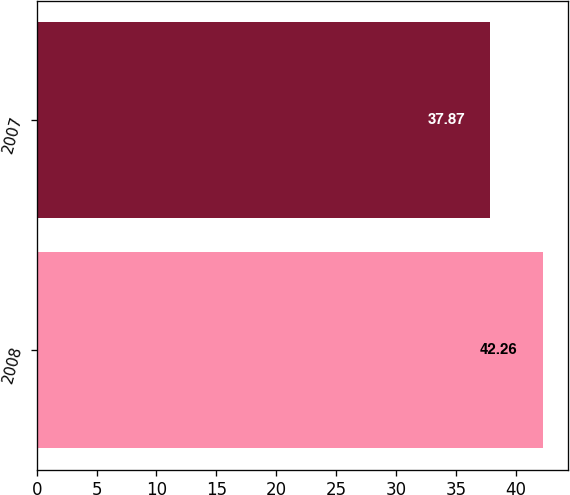<chart> <loc_0><loc_0><loc_500><loc_500><bar_chart><fcel>2008<fcel>2007<nl><fcel>42.26<fcel>37.87<nl></chart> 